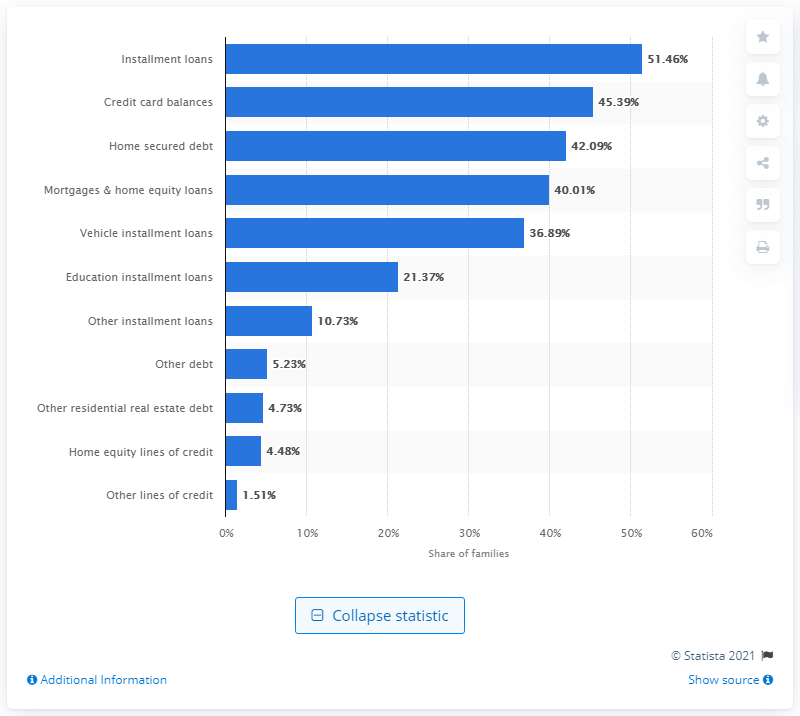Point out several critical features in this image. In 2019, 51.46% of families financed their needs through installment loans. 